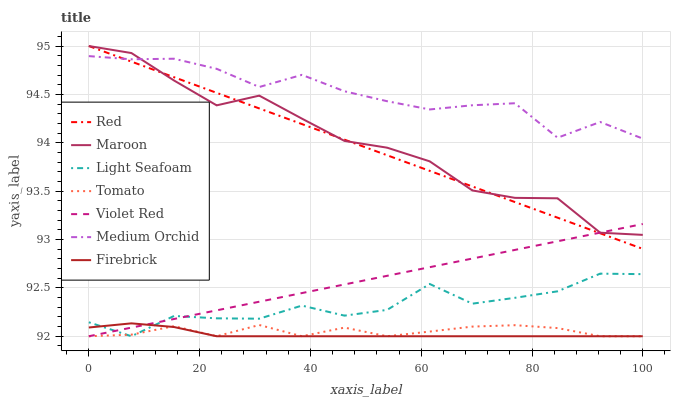Does Firebrick have the minimum area under the curve?
Answer yes or no. Yes. Does Medium Orchid have the maximum area under the curve?
Answer yes or no. Yes. Does Violet Red have the minimum area under the curve?
Answer yes or no. No. Does Violet Red have the maximum area under the curve?
Answer yes or no. No. Is Red the smoothest?
Answer yes or no. Yes. Is Light Seafoam the roughest?
Answer yes or no. Yes. Is Violet Red the smoothest?
Answer yes or no. No. Is Violet Red the roughest?
Answer yes or no. No. Does Tomato have the lowest value?
Answer yes or no. Yes. Does Medium Orchid have the lowest value?
Answer yes or no. No. Does Red have the highest value?
Answer yes or no. Yes. Does Violet Red have the highest value?
Answer yes or no. No. Is Firebrick less than Red?
Answer yes or no. Yes. Is Red greater than Firebrick?
Answer yes or no. Yes. Does Violet Red intersect Light Seafoam?
Answer yes or no. Yes. Is Violet Red less than Light Seafoam?
Answer yes or no. No. Is Violet Red greater than Light Seafoam?
Answer yes or no. No. Does Firebrick intersect Red?
Answer yes or no. No. 